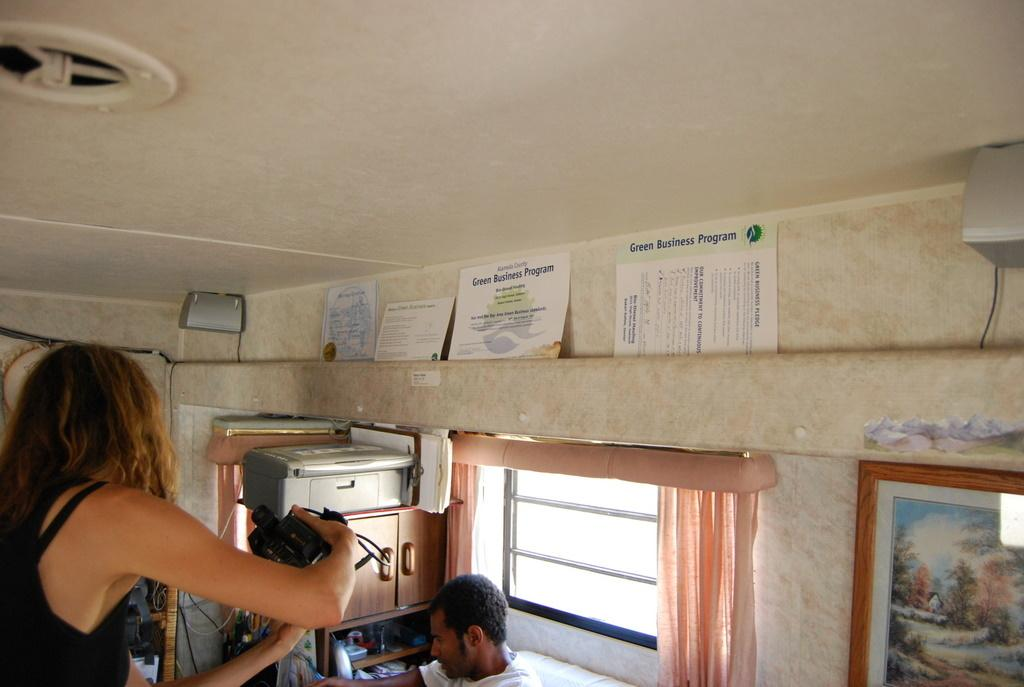<image>
Render a clear and concise summary of the photo. the top of a camper on the inside with a paper in it that says 'green business program' on it 